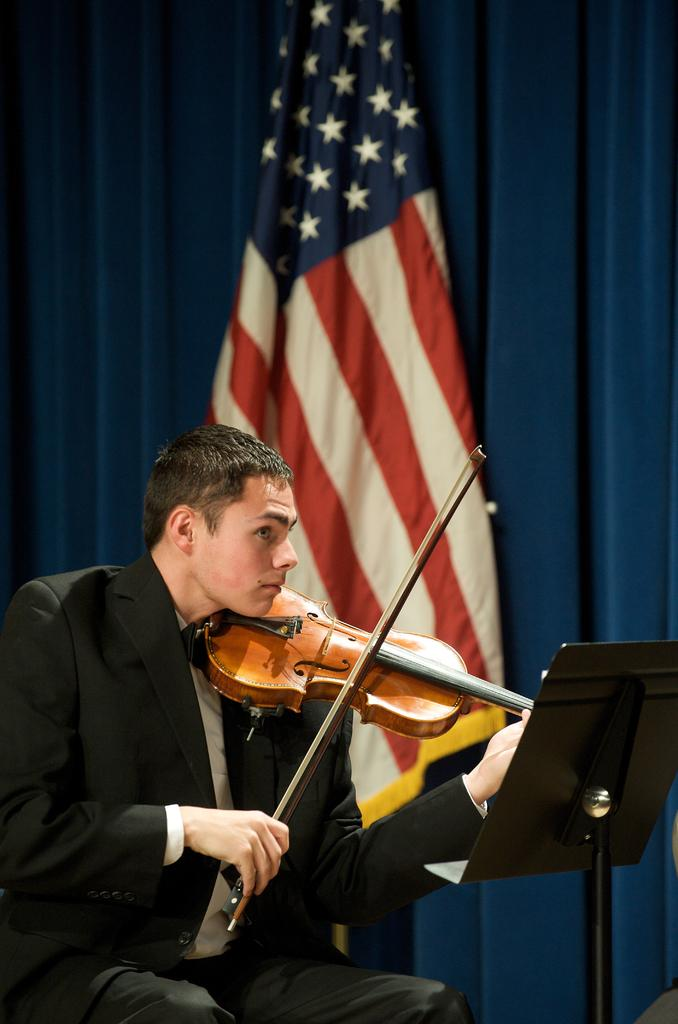What is the person in the image doing? The person is sitting on a chair and playing a violin. What is in front of the person? There is a blackboard in front of the person. What can be seen on the curtain in the image? There is a blue curtain visible, and an American flag is present on the curtain. What type of cream is being used to clean the violin in the image? There is no cream present in the image, nor is there any indication that the violin is being cleaned. 